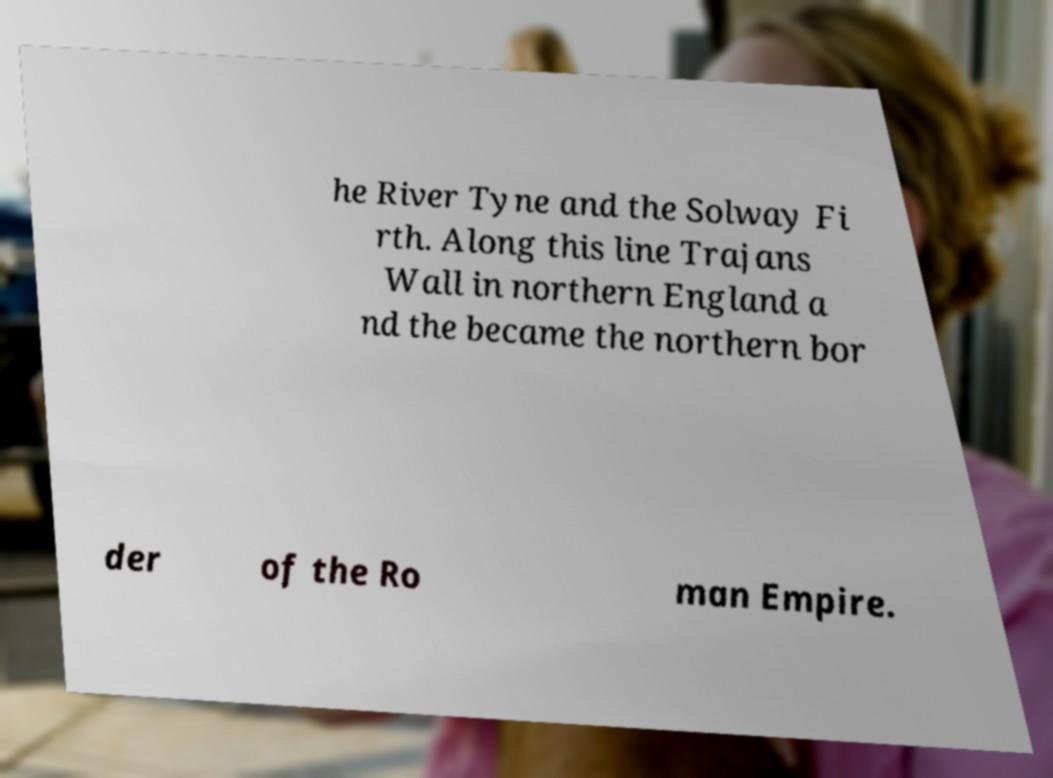Could you extract and type out the text from this image? he River Tyne and the Solway Fi rth. Along this line Trajans Wall in northern England a nd the became the northern bor der of the Ro man Empire. 